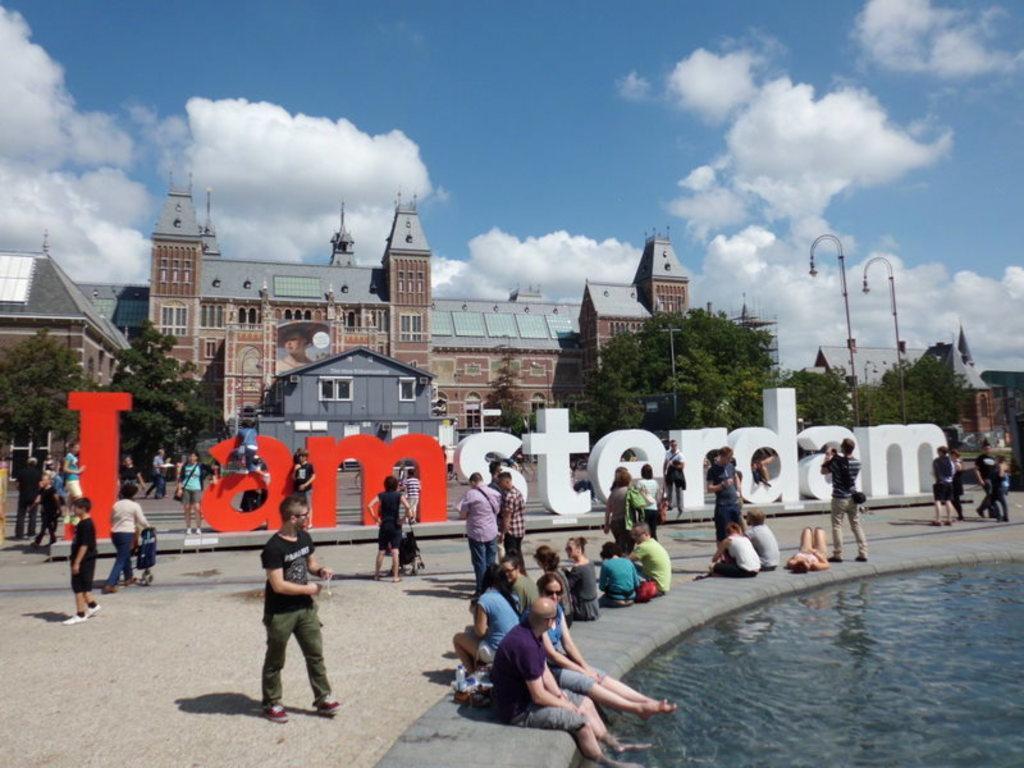In one or two sentences, can you explain what this image depicts? In this picture I am able to see a building. At the top of the picture I can see blue sky with some clouds and in the center of the picture that is written as I Am Sterdam and people are walking over here and some people are sitting over here. I can see a water pool at bottom right corner and there are some light poles in this picture. 